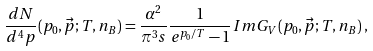Convert formula to latex. <formula><loc_0><loc_0><loc_500><loc_500>\frac { d N } { d ^ { 4 } p } ( p _ { 0 } , \vec { p } ; T , n _ { B } ) = \frac { \alpha ^ { 2 } } { \pi ^ { 3 } s } \frac { 1 } { e ^ { p _ { 0 } / T } - 1 } I m G _ { V } ( p _ { 0 } , \vec { p } ; T , n _ { B } ) \, ,</formula> 